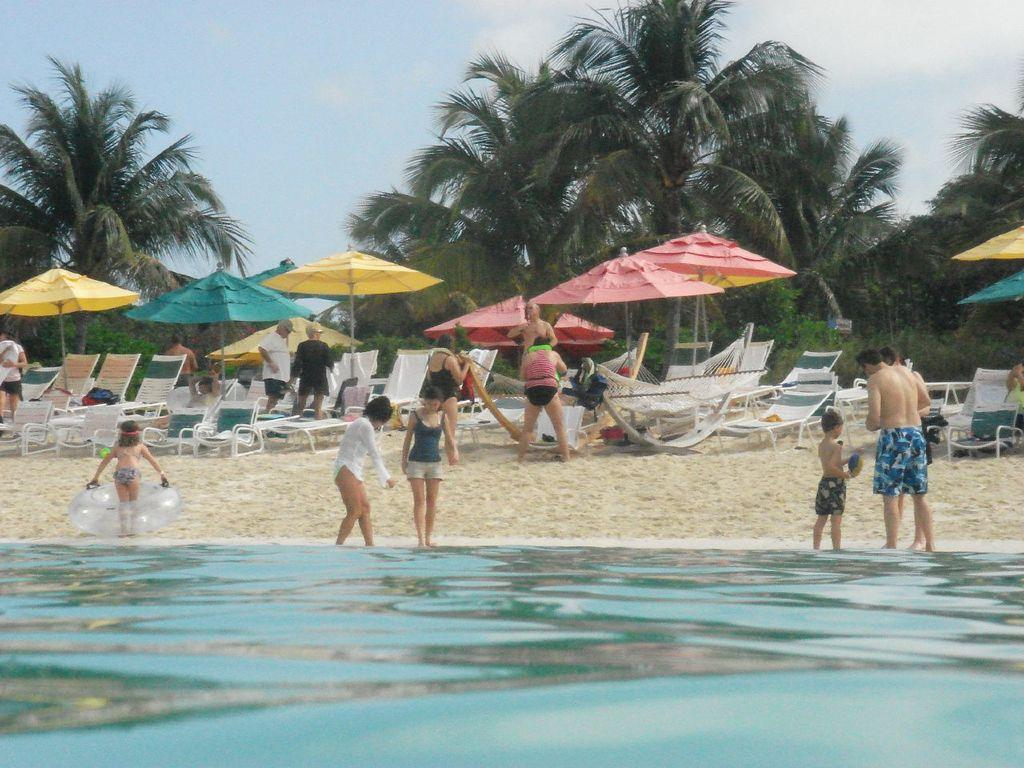What is in the foreground of the image? There is a water body in the foreground of the image. Can you describe the people in the image? There are people in the image. What type of furniture is present in the image? Beach chairs are present in the image. What type of shade is provided in the image? An umbrella is visible in the image. What type of terrain is visible in the image? Sand is present in the image. What type of vegetation is visible in the image? Trees and plants are present in the image. What is visible at the top of the image? The sky is visible at the top of the image. What type of sheet is draped over the water body in the image? There is no sheet present in the image; it features a water body in the foreground. What type of elbow is visible in the image? There is no elbow present in the image. 